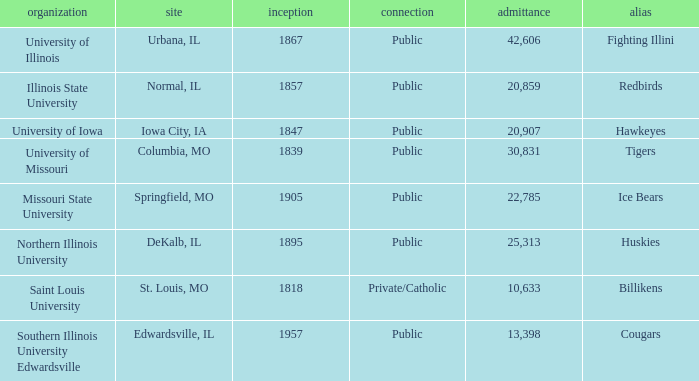What is Southern Illinois University Edwardsville's affiliation? Public. 